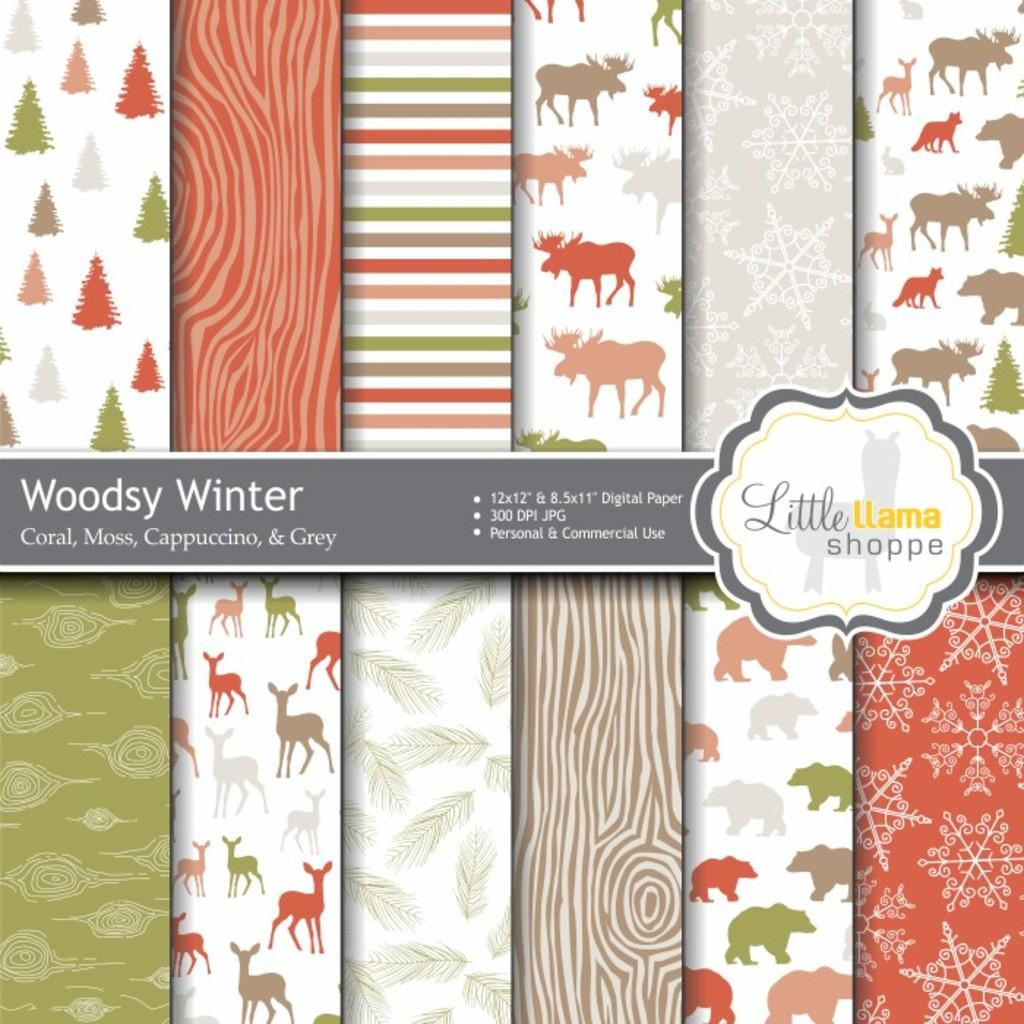What type of content is featured in the image? The image is an advertisement. What is located in the center of the image? There is a logo and text in the center of the image. What can be seen in the background of the image? There are different types of boards in the background of the image. What type of wren is sitting on the cushion in the image? There is no wren or cushion present in the image. How many pancakes are stacked on the table in the image? There is no table or pancakes present in the image. 